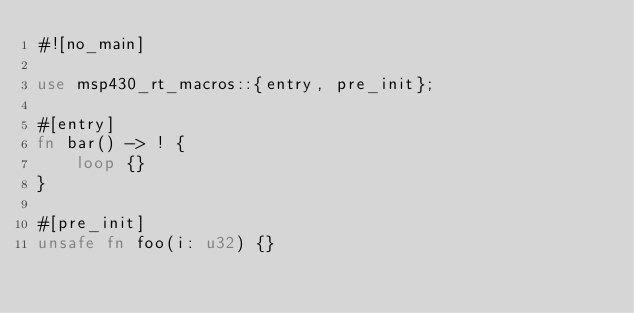Convert code to text. <code><loc_0><loc_0><loc_500><loc_500><_Rust_>#![no_main]

use msp430_rt_macros::{entry, pre_init};

#[entry]
fn bar() -> ! {
    loop {}
}

#[pre_init]
unsafe fn foo(i: u32) {}
</code> 